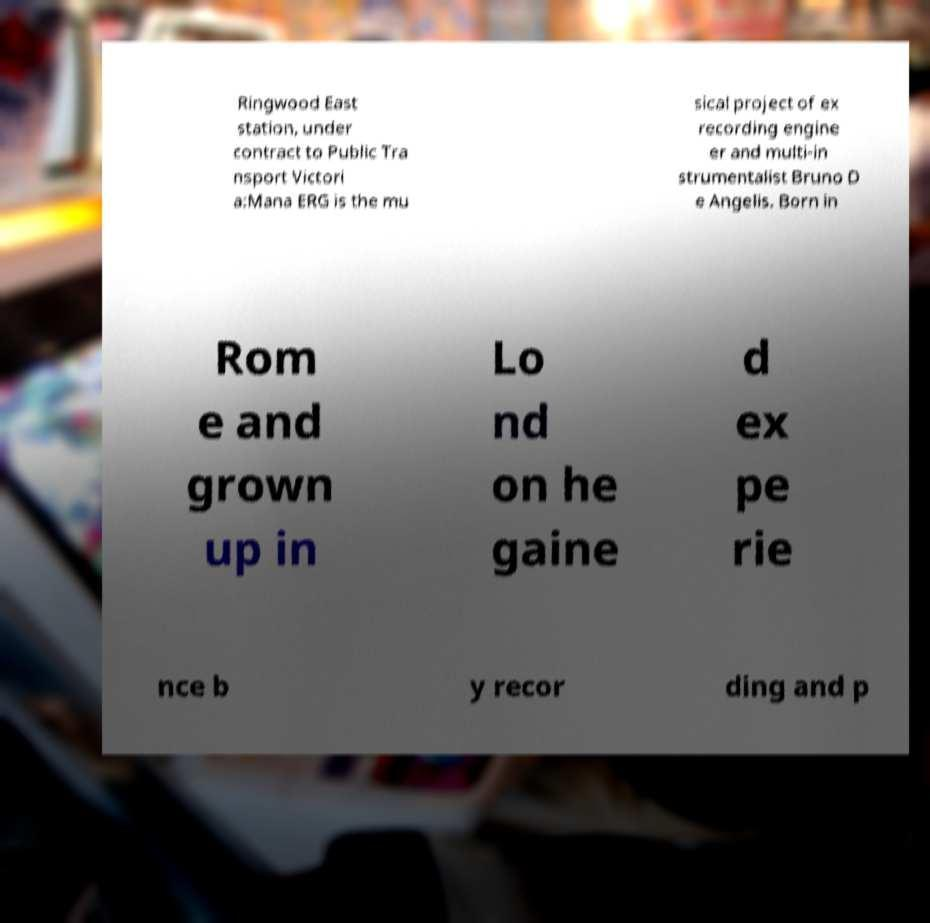Please read and relay the text visible in this image. What does it say? Ringwood East station, under contract to Public Tra nsport Victori a:Mana ERG is the mu sical project of ex recording engine er and multi-in strumentalist Bruno D e Angelis. Born in Rom e and grown up in Lo nd on he gaine d ex pe rie nce b y recor ding and p 